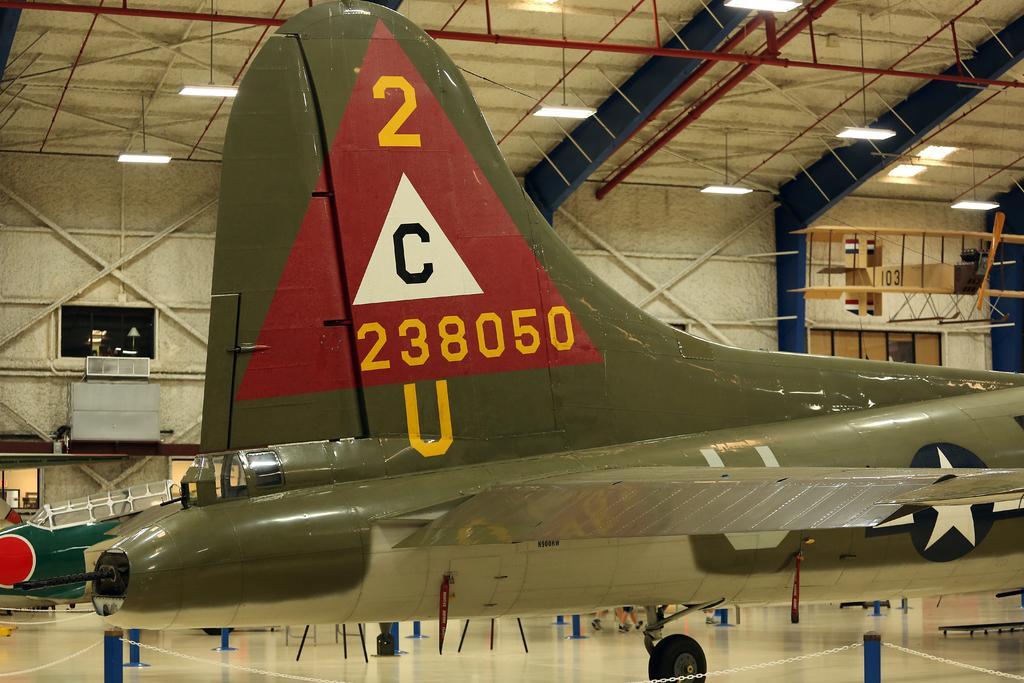<image>
Create a compact narrative representing the image presented. The tail of an old plane numbered 238050 in a museum 